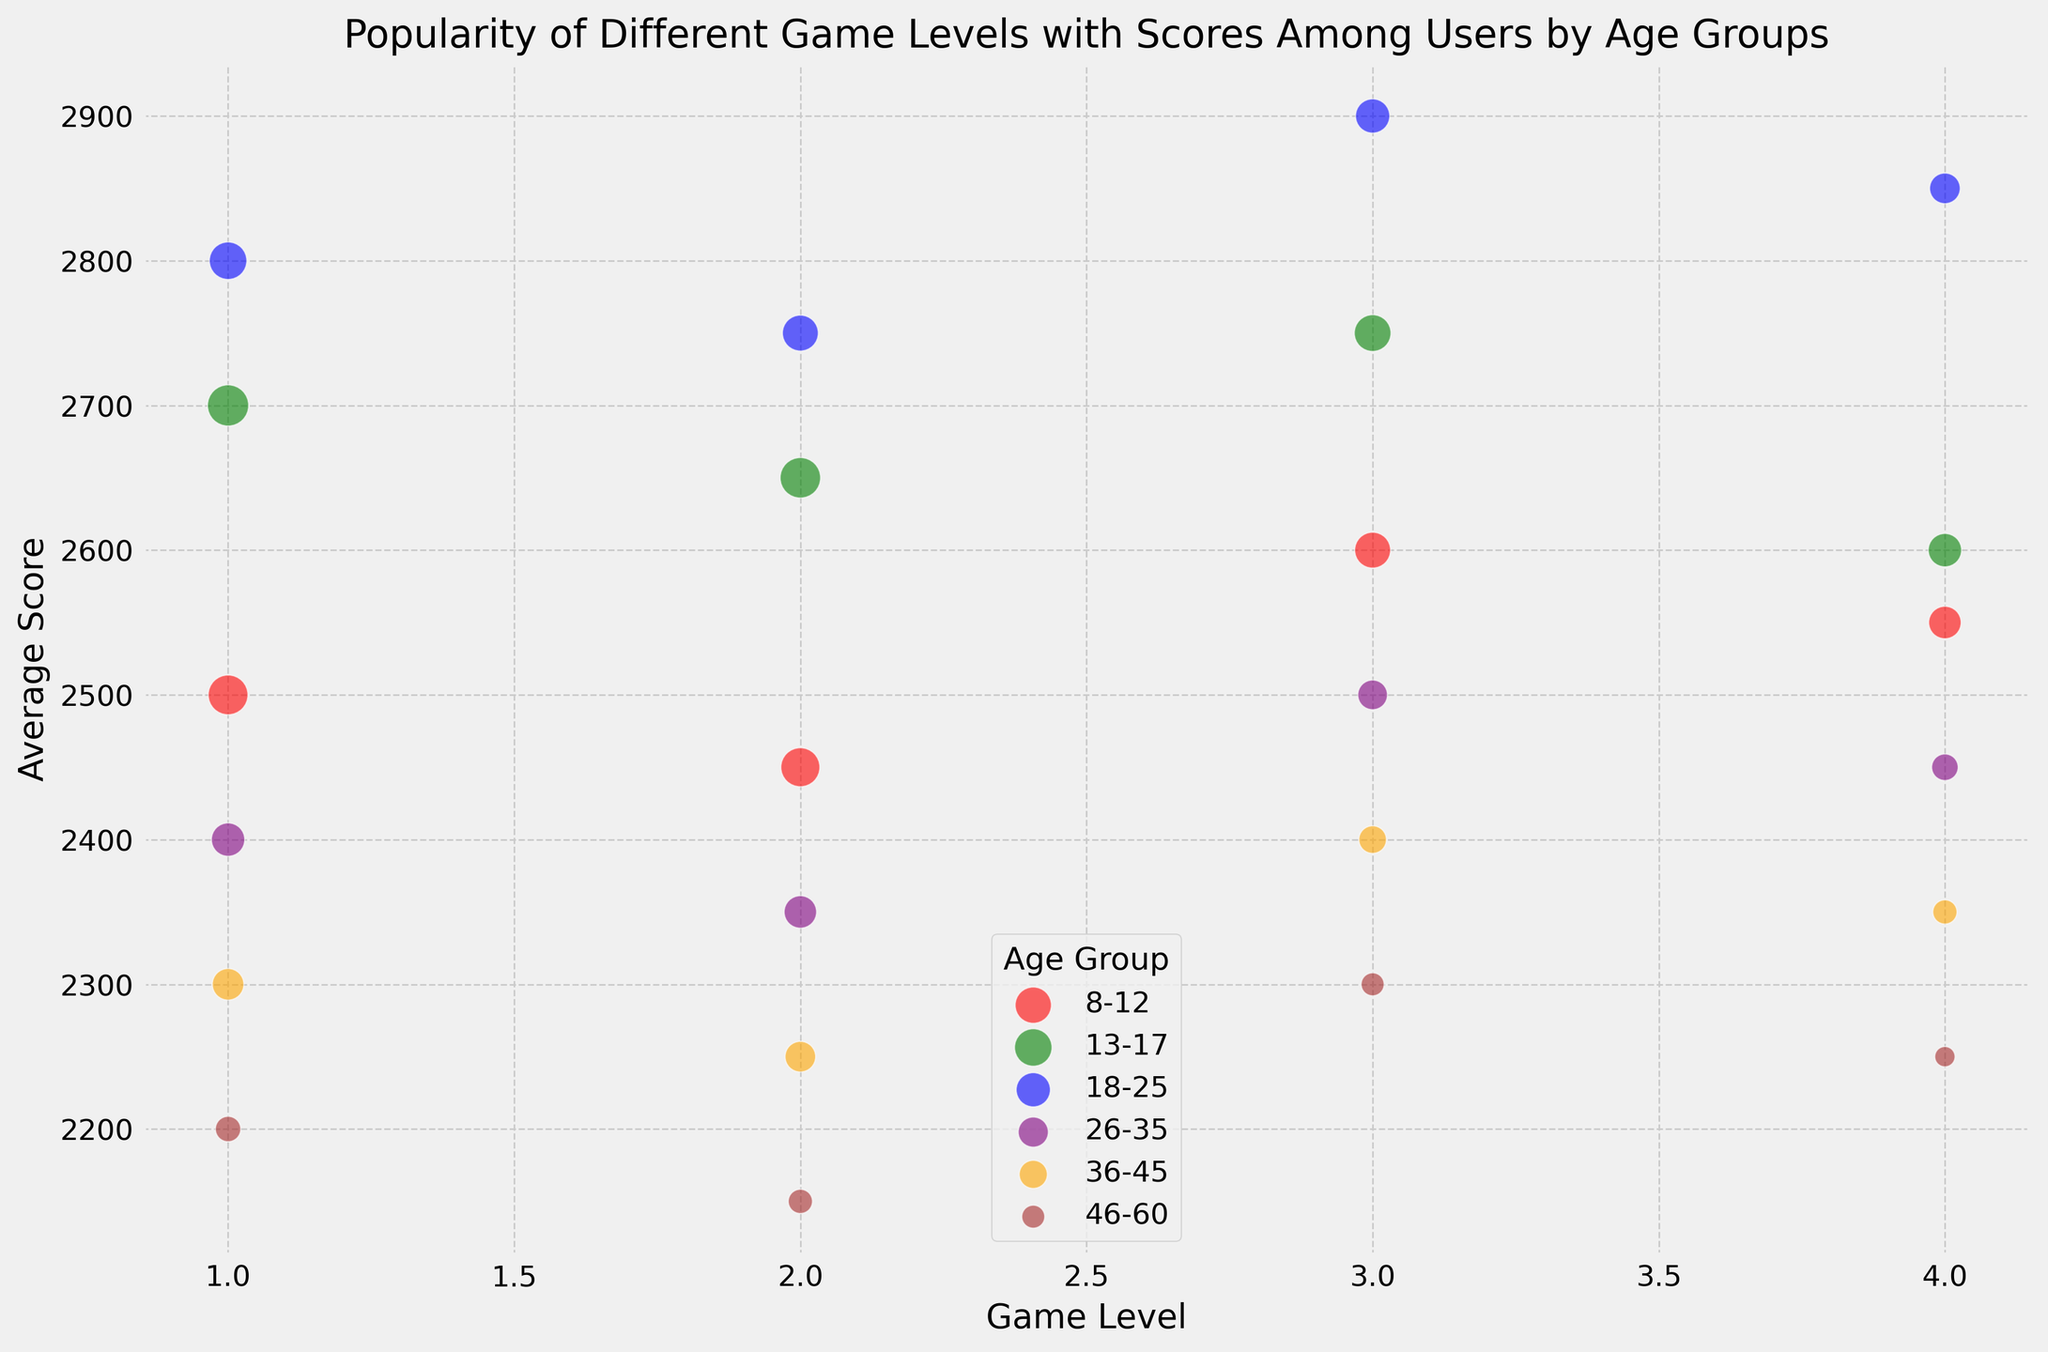What's the average score for game level 4 among the 13-17 age group? Find the green bubbles, which represent the 13-17 age group. Locate the bubble at game level 4. The average score is shown next to the bubble.
Answer: 2600 Which age group has the highest average score for game level 1? Compare the bubbles for game level 1 across different colors. The blue bubble (18-25 age group) at game level 1 is at the highest average score.
Answer: 18-25 What is the total user count for age group 36-45 across all game levels? Identify the orange bubbles for age group 36-45 and sum the user counts: 85 (level 1) + 80 (level 2) + 65 (level 3) + 50 (level 4).
Answer: 280 For game level 3, which age group scores the highest? Check the positions of the bubbles at game level 3. The highest average score is for the blue bubble (18-25 age group).
Answer: 18-25 Which game level has the smallest user count for the 46-60 age group? Look at the brown bubbles representing 46-60 age group. Then locate the smallest bubble: game level 4.
Answer: Level 4 Comparing bubbles representing the 26-35 age group, which game level shows the highest average score? Find purple bubbles for 26-35 age group and compare their average scores. The highest score is at game level 3.
Answer: Level 3 What is the difference in average scores between game level 2 and game level 4 for the 8-12 age group? Find the red bubbles for levels 2 and 4 in 8-12 age group. Subtract the average score of level 2 (2450) from level 4 (2550): 2550 - 2450.
Answer: 100 Which age group has the lowest average score for game level 2? Compare the bubbles at game level 2 for different age groups. The lowest position is the brown bubble (46-60 age group).
Answer: 46-60 What is the sum of the user counts at game level 1 across all age groups? Add user counts for level 1 across all bubbles: 135 (8-12) + 145 (13-17) + 120 (18-25) + 95 (26-35) + 85 (36-45) + 55 (46-60).
Answer: 635 